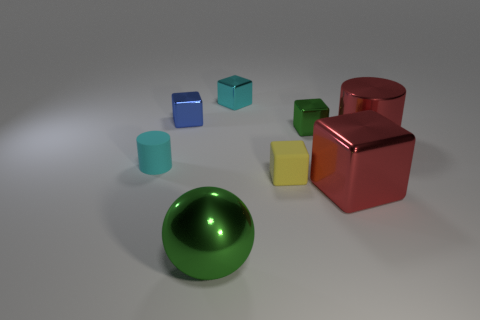Are there fewer large balls on the right side of the matte block than big blue blocks?
Offer a terse response. No. The green thing that is the same size as the red cylinder is what shape?
Make the answer very short. Sphere. How many other things are there of the same color as the shiny cylinder?
Offer a very short reply. 1. Do the red metal cylinder and the cyan cube have the same size?
Keep it short and to the point. No. How many objects are either red shiny things or small metal blocks that are in front of the blue shiny block?
Your response must be concise. 3. Is the number of large metallic cylinders in front of the ball less than the number of tiny blue metallic blocks in front of the blue metal object?
Ensure brevity in your answer.  No. What number of other things are made of the same material as the red cube?
Make the answer very short. 5. There is a cylinder in front of the big red shiny cylinder; does it have the same color as the sphere?
Ensure brevity in your answer.  No. Is there a cyan shiny cube behind the tiny rubber object that is right of the big green shiny thing?
Ensure brevity in your answer.  Yes. What is the block that is both on the right side of the yellow matte block and behind the red metallic cube made of?
Offer a terse response. Metal. 